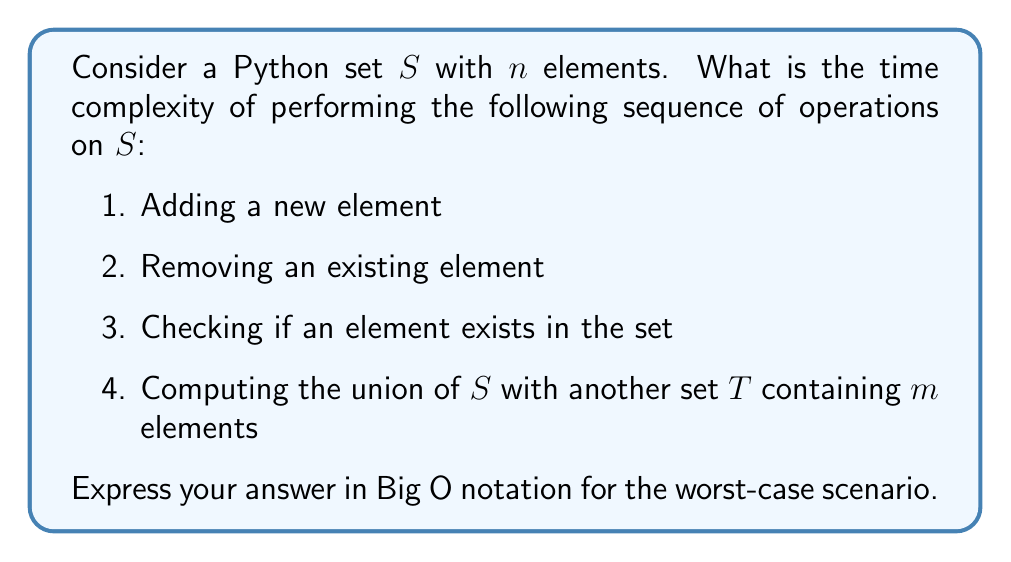Solve this math problem. Let's analyze each operation step by step:

1. Adding a new element:
   In Python, sets are implemented as hash tables. Adding an element to a hash table has an average time complexity of $O(1)$, but in the worst case (when rehashing is required), it can be $O(n)$.

2. Removing an existing element:
   Similar to adding, removal in a hash table has an average time complexity of $O(1)$, but in the worst case, it can be $O(n)$.

3. Checking if an element exists in the set:
   Membership testing in a hash table is $O(1)$ on average, but in the worst case (due to hash collisions), it can be $O(n)$.

4. Computing the union of $S$ with another set $T$:
   The union operation in Python creates a new set containing all unique elements from both sets. This involves:
   - Creating a new set: $O(n)$ (where $n$ is the size of the larger set)
   - Iterating through all elements of both sets: $O(n + m)$
   - Adding each element to the new set: $O(1)$ on average, but $O(n+m)$ in the worst case for each addition

   Therefore, the overall complexity of the union operation is $O(n + m)$ on average, but $O((n+m)^2)$ in the worst case.

Combining all these operations, the worst-case time complexity is dominated by the union operation, which is $O((n+m)^2)$.

However, it's important to note that this worst-case scenario is extremely rare in practice. The average-case time complexity would be $O(n + m)$.
Answer: The worst-case time complexity for the given sequence of operations is $O((n+m)^2)$, where $n$ is the number of elements in set $S$ and $m$ is the number of elements in set $T$. 